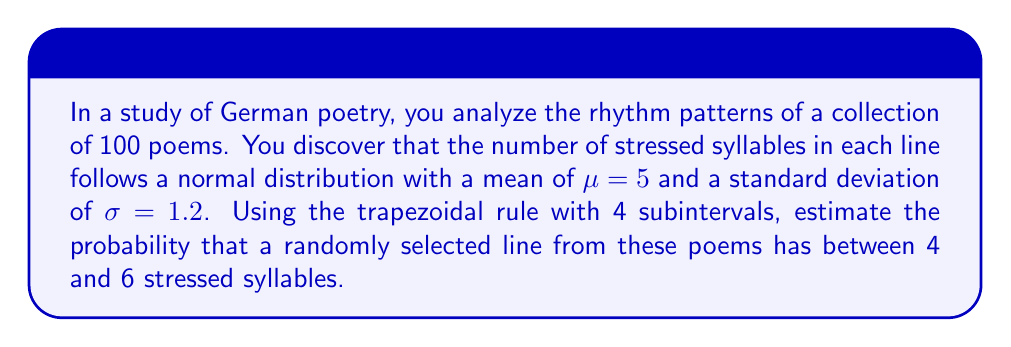What is the answer to this math problem? To solve this problem, we'll follow these steps:

1) The probability we're looking for is the area under the normal distribution curve between 4 and 6.

2) For a normal distribution, we need to standardize these values:
   $z_1 = \frac{4 - \mu}{\sigma} = \frac{4 - 5}{1.2} = -0.8333$
   $z_2 = \frac{6 - \mu}{\sigma} = \frac{6 - 5}{1.2} = 0.8333$

3) The probability is given by the integral:
   $P(4 \leq X \leq 6) = \int_{-0.8333}^{0.8333} \frac{1}{\sqrt{2\pi}} e^{-\frac{z^2}{2}} dz$

4) We'll use the trapezoidal rule with 4 subintervals. The formula is:
   $\int_a^b f(x)dx \approx \frac{h}{2}[f(x_0) + 2f(x_1) + 2f(x_2) + 2f(x_3) + f(x_4)]$
   where $h = \frac{b-a}{n}$, $n$ is the number of subintervals, and $x_i = a + ih$

5) Calculate $h$:
   $h = \frac{0.8333 - (-0.8333)}{4} = 0.4167$

6) Calculate the $x_i$ values:
   $x_0 = -0.8333$
   $x_1 = -0.4166$
   $x_2 = 0$
   $x_3 = 0.4166$
   $x_4 = 0.8333$

7) Calculate $f(x_i) = \frac{1}{\sqrt{2\pi}} e^{-\frac{x_i^2}{2}}$ for each $x_i$:
   $f(x_0) = 0.2820$
   $f(x_1) = 0.3652$
   $f(x_2) = 0.3989$
   $f(x_3) = 0.3652$
   $f(x_4) = 0.2820$

8) Apply the trapezoidal rule:
   $\int_{-0.8333}^{0.8333} f(x)dx \approx \frac{0.4167}{2}[0.2820 + 2(0.3652) + 2(0.3989) + 2(0.3652) + 0.2820]$
   $= 0.2083[0.2820 + 0.7304 + 0.7978 + 0.7304 + 0.2820]$
   $= 0.2083(2.8226) = 0.5879$

Therefore, the estimated probability is approximately 0.5879 or 58.79%.
Answer: 0.5879 